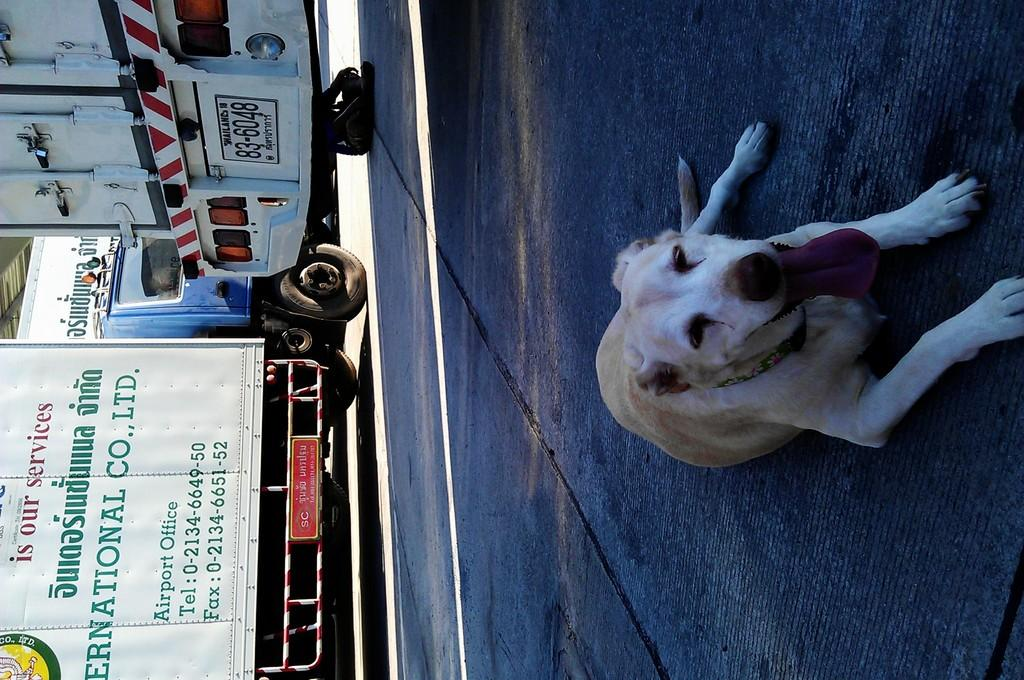What can be seen on the left side of the image? There are vehicles on the road on the left side of the image. What is present on the right side of the image? There is a dog on the right side of the image. Can you describe the time of day when the image was taken? The image appears to be taken during the day. What type of lead is the dog using to play baseball in the image? There is no dog playing baseball in the image, nor is there any lead present. 